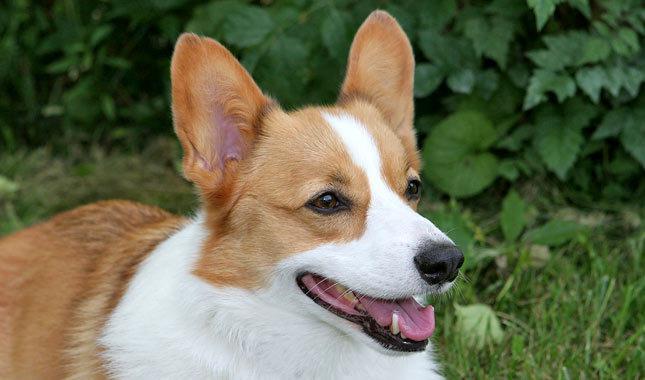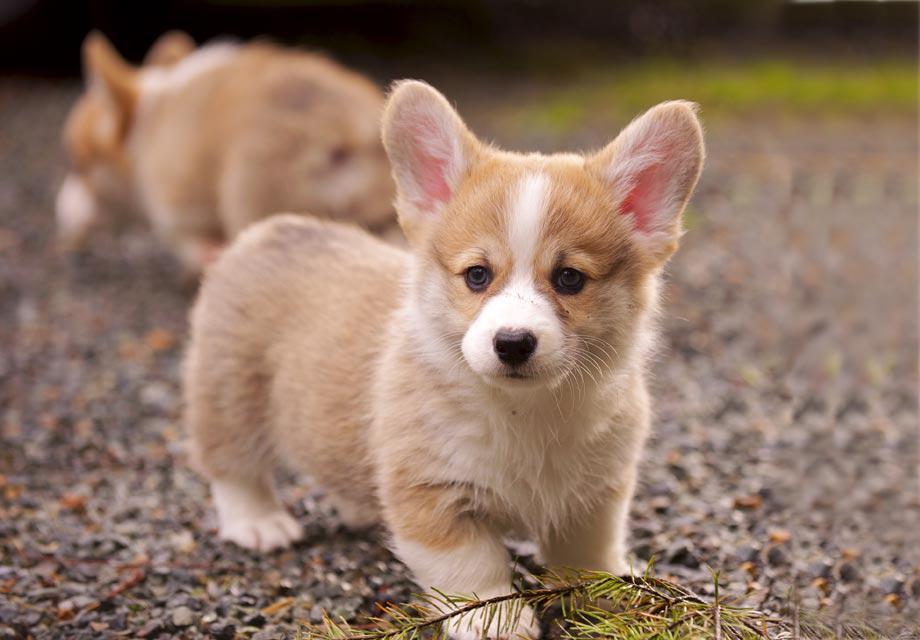The first image is the image on the left, the second image is the image on the right. Evaluate the accuracy of this statement regarding the images: "All dogs are on a natural surface outside.". Is it true? Answer yes or no. Yes. 